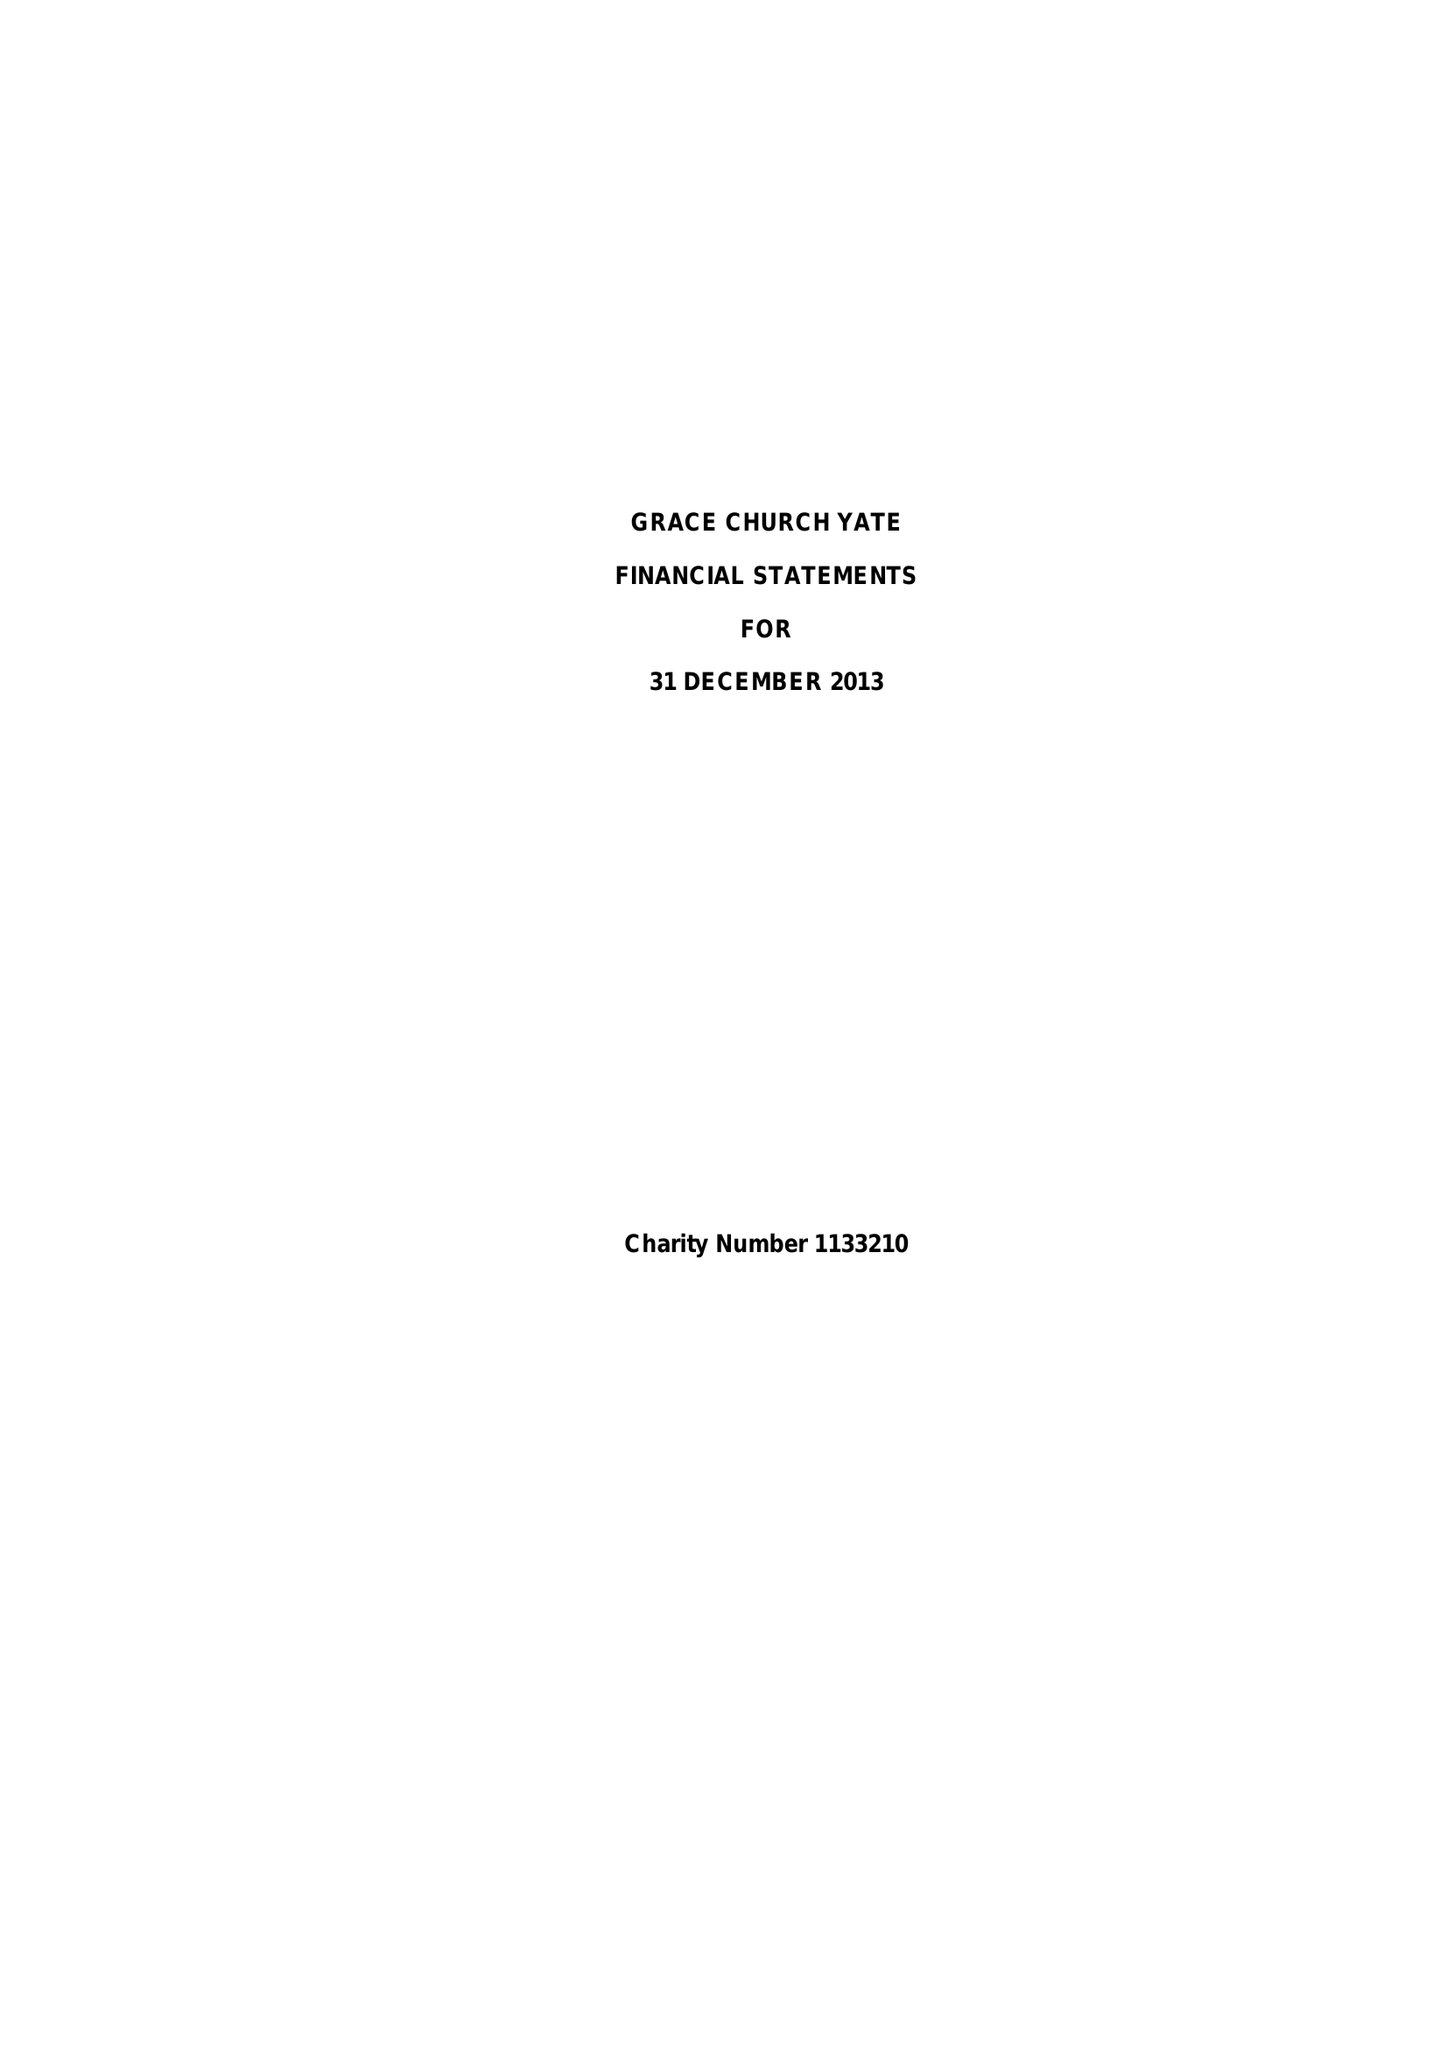What is the value for the spending_annually_in_british_pounds?
Answer the question using a single word or phrase. 221029.00 